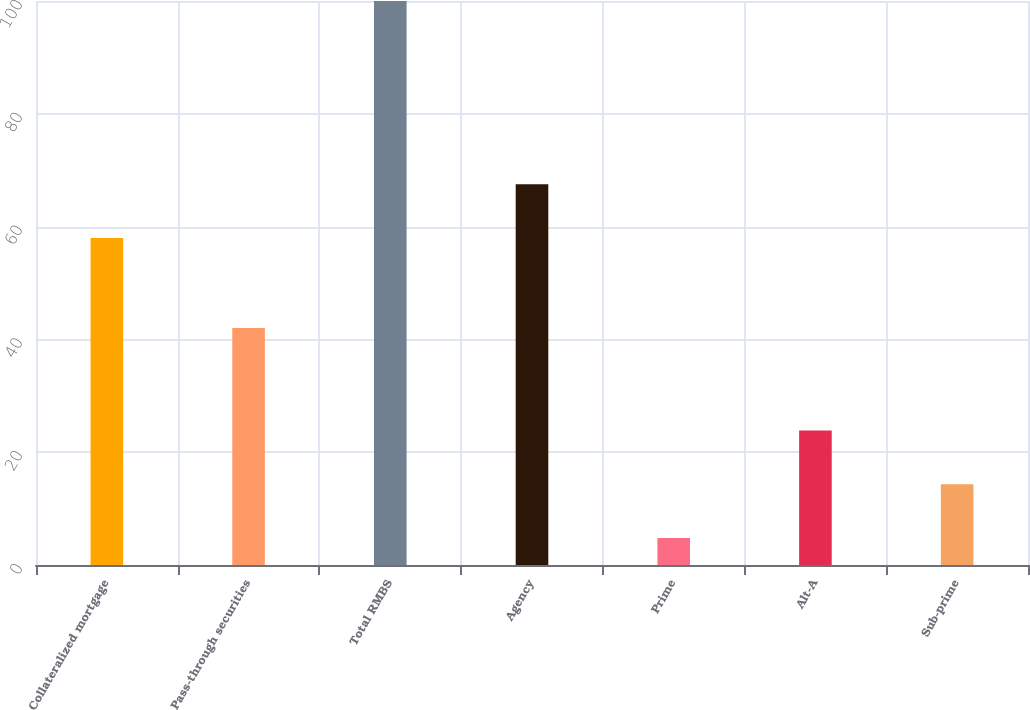Convert chart to OTSL. <chart><loc_0><loc_0><loc_500><loc_500><bar_chart><fcel>Collateralized mortgage<fcel>Pass-through securities<fcel>Total RMBS<fcel>Agency<fcel>Prime<fcel>Alt-A<fcel>Sub-prime<nl><fcel>58<fcel>42<fcel>100<fcel>67.52<fcel>4.8<fcel>23.84<fcel>14.32<nl></chart> 